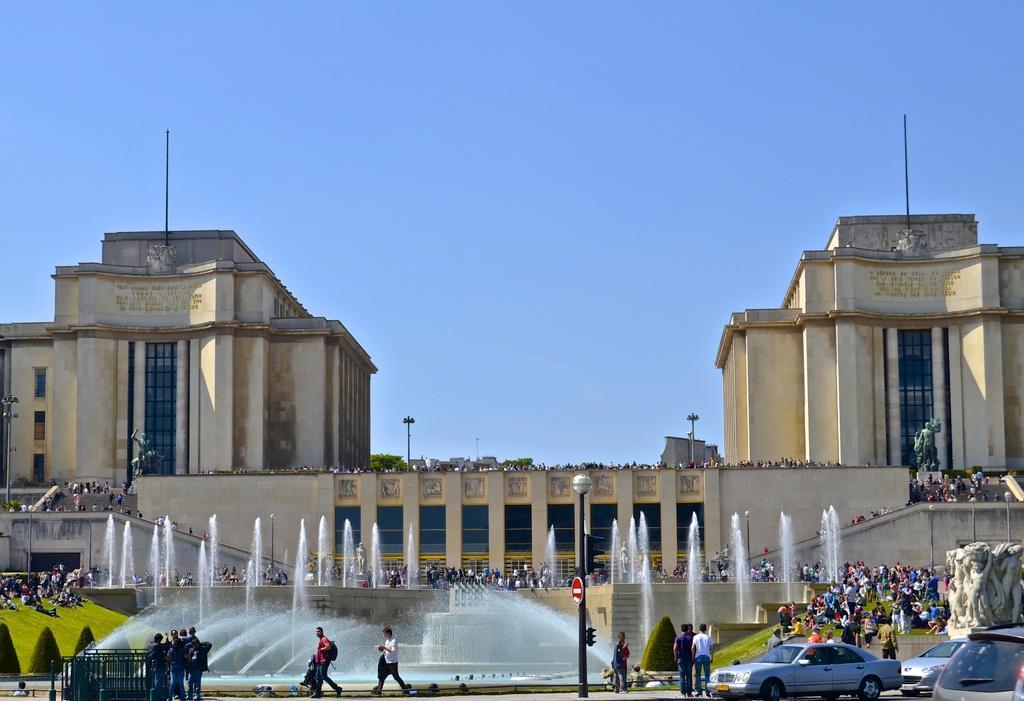How would you summarize this image in a sentence or two? In this image I can see few people walking on the road. I can also see few vehicles, light poles, waterfalls. At back the building is in cream color and sky is in blue color. 